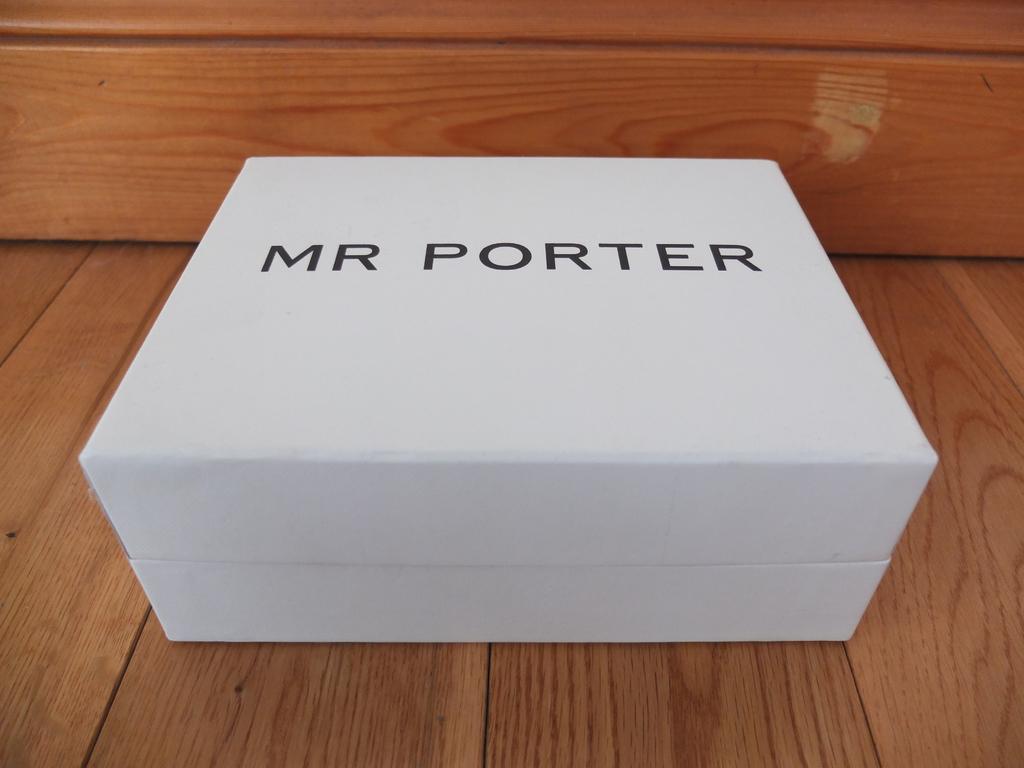What is the brand of the item in this box?
Offer a terse response. Mr porter. What gender is the person listed?
Your answer should be compact. Male. 